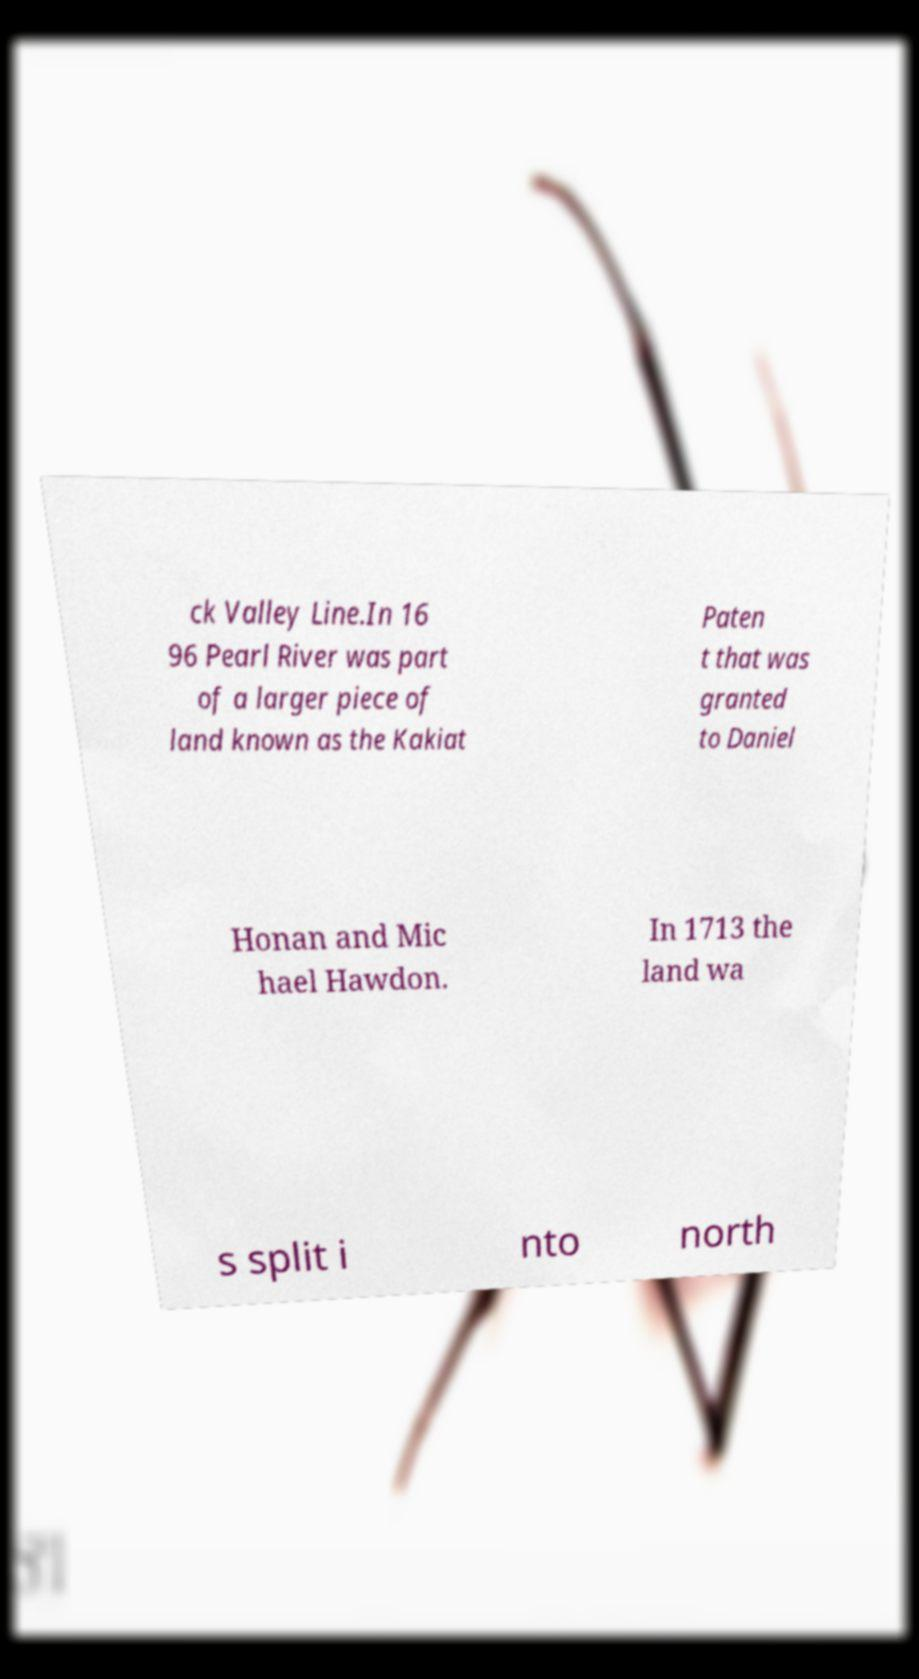Can you accurately transcribe the text from the provided image for me? ck Valley Line.In 16 96 Pearl River was part of a larger piece of land known as the Kakiat Paten t that was granted to Daniel Honan and Mic hael Hawdon. In 1713 the land wa s split i nto north 